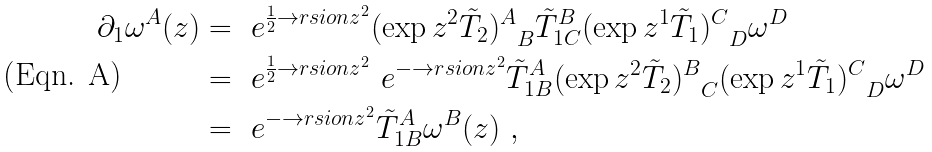Convert formula to latex. <formula><loc_0><loc_0><loc_500><loc_500>\partial _ { 1 } \omega ^ { A } ( z ) & = \ e ^ { \frac { 1 } { 2 } \to r s i o n z ^ { 2 } } { ( \exp { z ^ { 2 } { \tilde { T } } _ { 2 } } ) ^ { A } } _ { B } { \tilde { T } } ^ { B } _ { 1 C } { ( \exp { z ^ { 1 } { \tilde { T } } _ { 1 } } ) ^ { C } } _ { D } \omega ^ { D } \\ & = \ e ^ { \frac { 1 } { 2 } \to r s i o n z ^ { 2 } } \ e ^ { - \to r s i o n z ^ { 2 } } { \tilde { T } } ^ { A } _ { 1 B } { ( \exp { z ^ { 2 } { \tilde { T } } _ { 2 } } ) ^ { B } } _ { C } { ( \exp { z ^ { 1 } { \tilde { T } } _ { 1 } } ) ^ { C } } _ { D } \omega ^ { D } \\ & = \ e ^ { - \to r s i o n z ^ { 2 } } { \tilde { T } } ^ { A } _ { 1 B } \omega ^ { B } ( z ) \ ,</formula> 